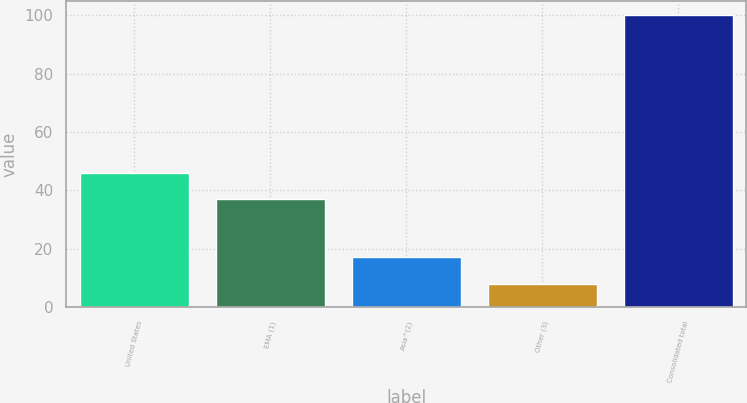<chart> <loc_0><loc_0><loc_500><loc_500><bar_chart><fcel>United States<fcel>EMA (1)<fcel>Asia^(2)<fcel>Other (3)<fcel>Consolidated total<nl><fcel>46.12<fcel>36.9<fcel>17.1<fcel>7.8<fcel>100<nl></chart> 